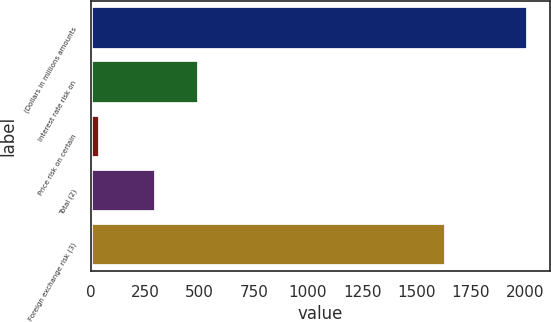Convert chart to OTSL. <chart><loc_0><loc_0><loc_500><loc_500><bar_chart><fcel>(Dollars in millions amounts<fcel>Interest rate risk on<fcel>Price risk on certain<fcel>Total (2)<fcel>Foreign exchange risk (3)<nl><fcel>2016<fcel>496.5<fcel>41<fcel>299<fcel>1636<nl></chart> 